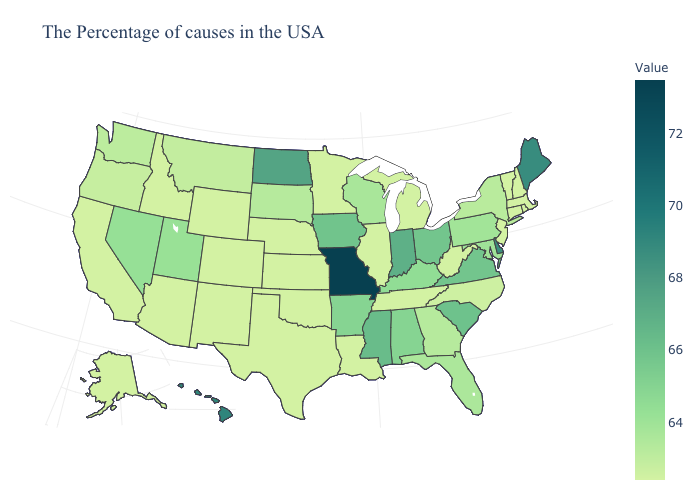Does Missouri have the highest value in the USA?
Concise answer only. Yes. Among the states that border Kentucky , does Virginia have the lowest value?
Short answer required. No. Does Connecticut have the lowest value in the Northeast?
Answer briefly. Yes. Among the states that border Illinois , does Kentucky have the lowest value?
Short answer required. No. Does the map have missing data?
Keep it brief. No. Does New Jersey have the lowest value in the USA?
Quick response, please. Yes. Among the states that border Connecticut , which have the highest value?
Write a very short answer. New York. 